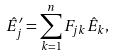Convert formula to latex. <formula><loc_0><loc_0><loc_500><loc_500>\hat { E } _ { j } ^ { \prime } = \sum _ { k = 1 } ^ { n } F _ { j k } \hat { E } _ { k } ,</formula> 